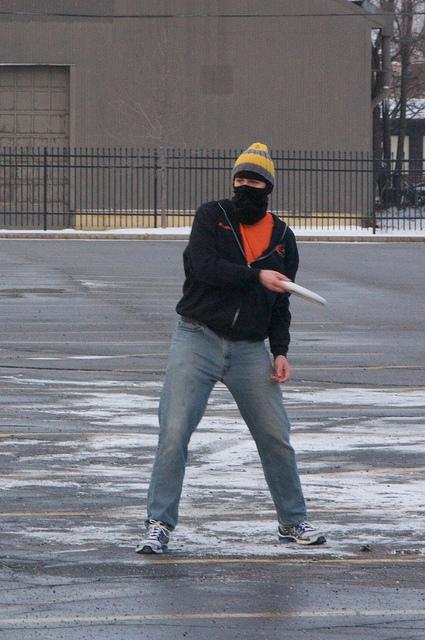What is the man holding?
Give a very brief answer. Frisbee. What color shirt is the man wearing?
Give a very brief answer. Orange. What is the person doing?
Give a very brief answer. Frisbee. What is the person holding?
Write a very short answer. Frisbee. 